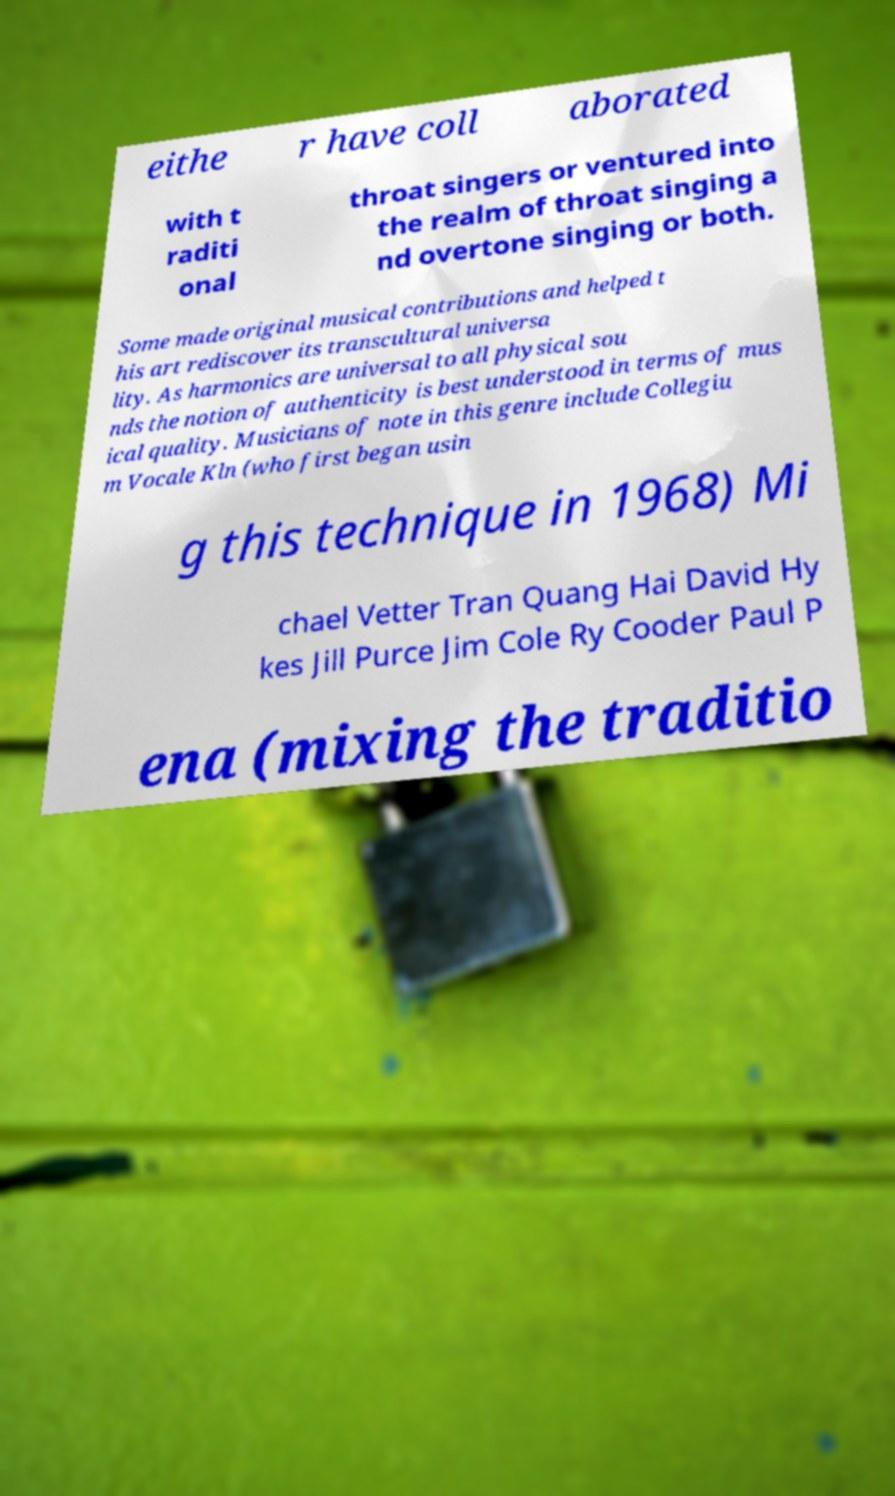Please read and relay the text visible in this image. What does it say? eithe r have coll aborated with t raditi onal throat singers or ventured into the realm of throat singing a nd overtone singing or both. Some made original musical contributions and helped t his art rediscover its transcultural universa lity. As harmonics are universal to all physical sou nds the notion of authenticity is best understood in terms of mus ical quality. Musicians of note in this genre include Collegiu m Vocale Kln (who first began usin g this technique in 1968) Mi chael Vetter Tran Quang Hai David Hy kes Jill Purce Jim Cole Ry Cooder Paul P ena (mixing the traditio 